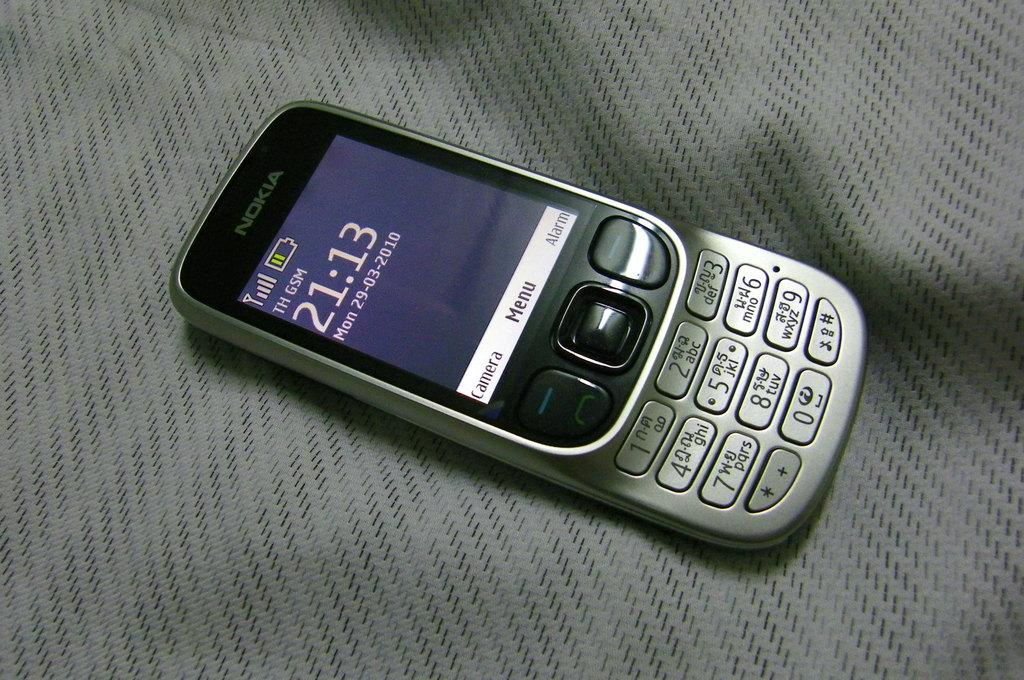<image>
Share a concise interpretation of the image provided. The day of the week on the display of this phone is a Monday. 